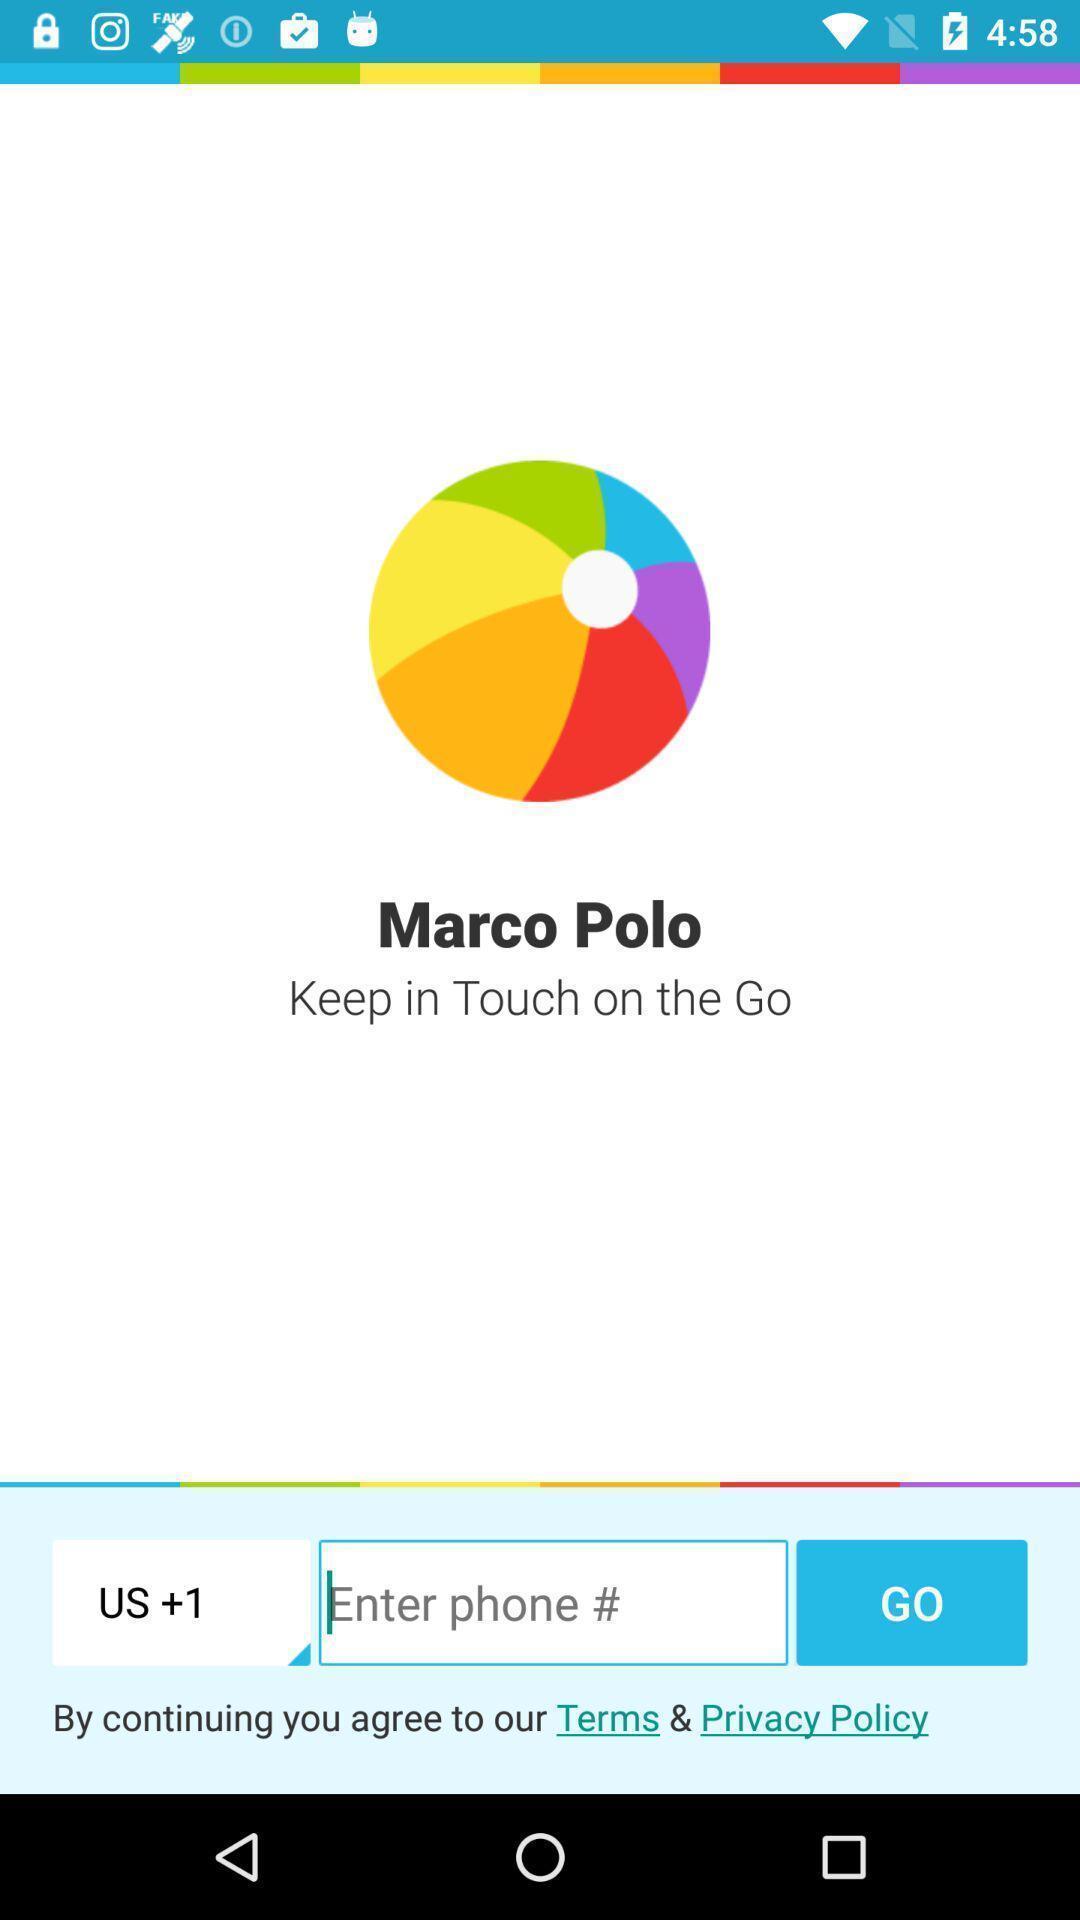Describe this image in words. Screen shows enter phone. 